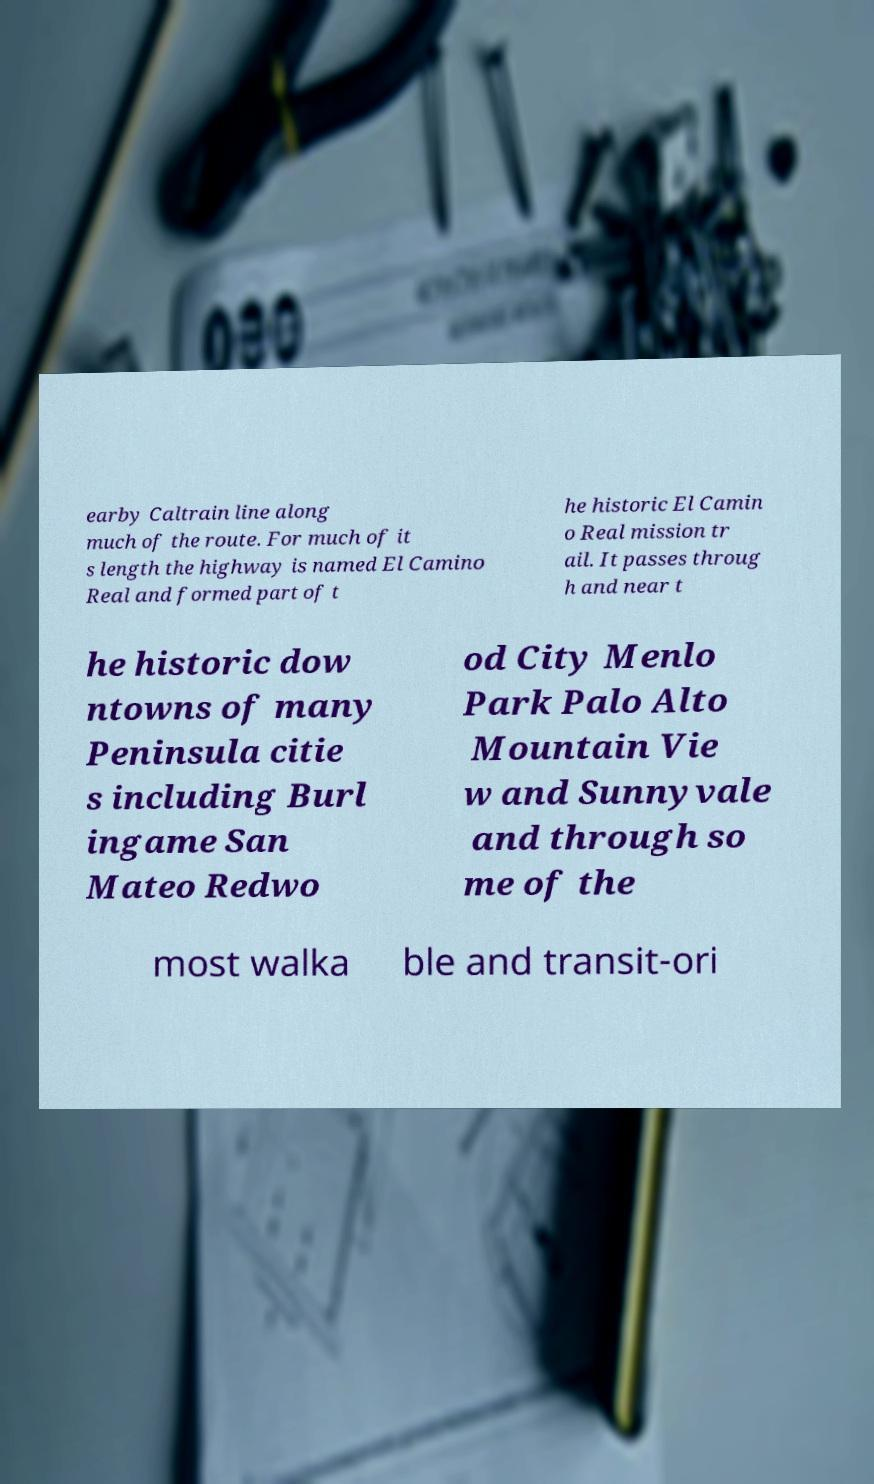Could you extract and type out the text from this image? earby Caltrain line along much of the route. For much of it s length the highway is named El Camino Real and formed part of t he historic El Camin o Real mission tr ail. It passes throug h and near t he historic dow ntowns of many Peninsula citie s including Burl ingame San Mateo Redwo od City Menlo Park Palo Alto Mountain Vie w and Sunnyvale and through so me of the most walka ble and transit-ori 